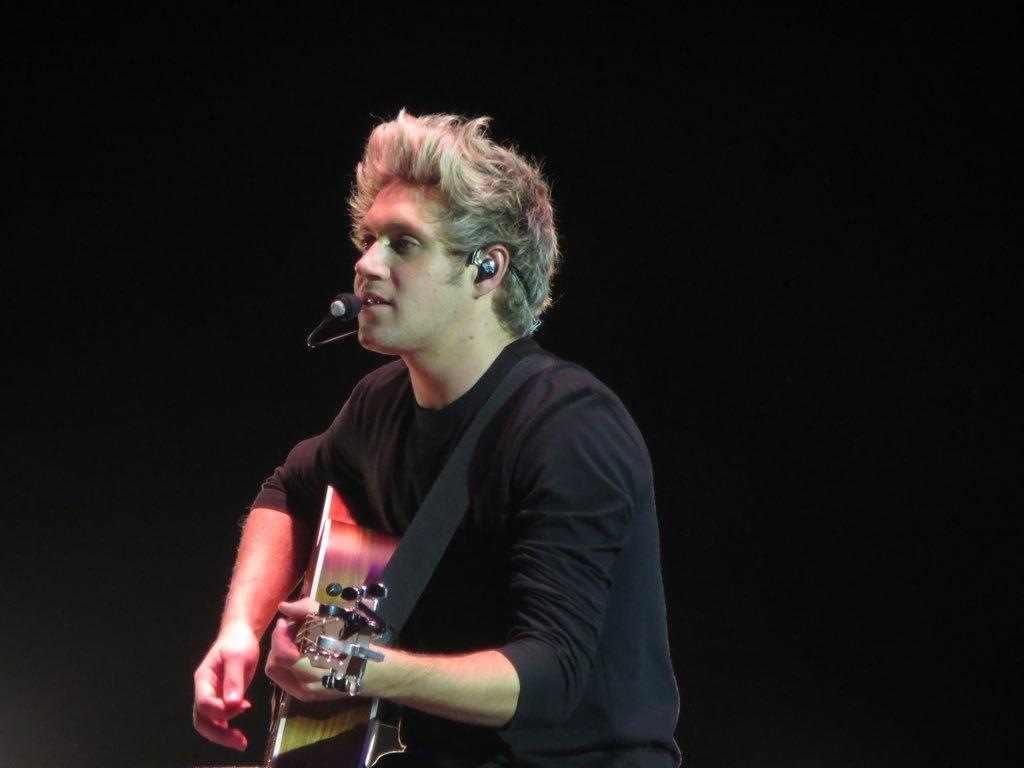Who is the main subject in the image? There is a man in the image. What is the man doing in the image? The man is standing, playing a guitar, and singing. What type of arch can be seen in the background of the image? There is no arch present in the image; it only features a man standing, playing a guitar, and singing. 